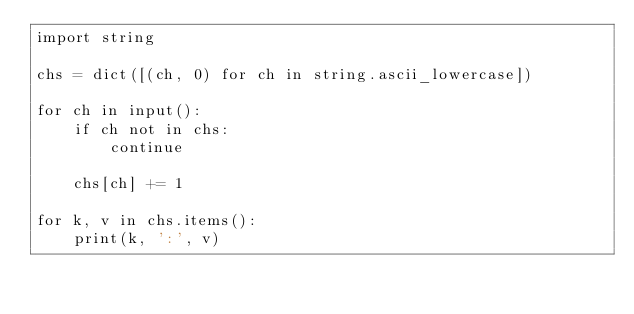<code> <loc_0><loc_0><loc_500><loc_500><_Python_>import string

chs = dict([(ch, 0) for ch in string.ascii_lowercase])

for ch in input():
    if ch not in chs:
        continue

    chs[ch] += 1

for k, v in chs.items():
    print(k, ':', v)</code> 